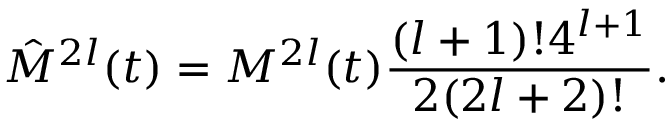<formula> <loc_0><loc_0><loc_500><loc_500>\hat { M } ^ { 2 l } ( t ) = M ^ { 2 l } ( t ) \frac { ( l + 1 ) ! 4 ^ { l + 1 } } { 2 ( 2 l + 2 ) ! } .</formula> 